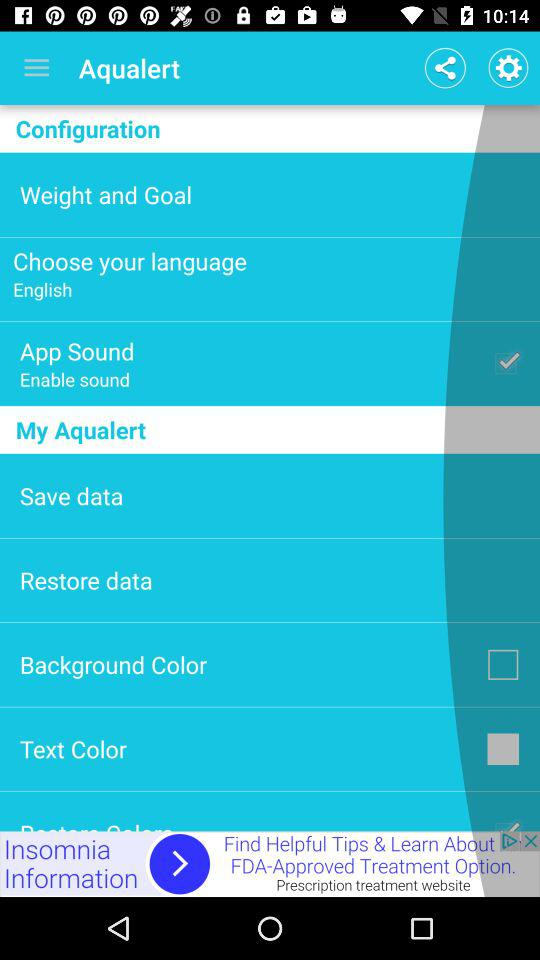What is the status of the background colour? The background colour is "White". 